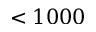Convert formula to latex. <formula><loc_0><loc_0><loc_500><loc_500>< 1 0 0 0</formula> 